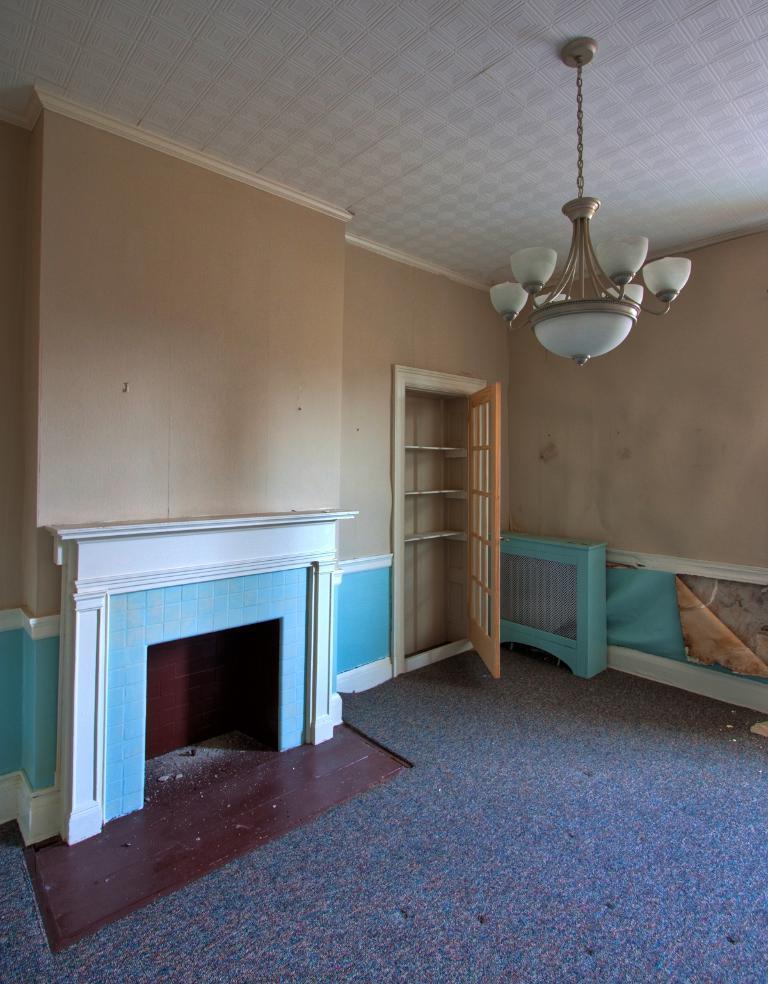How would you summarize this image in a sentence or two? In this image we can see the fire place, floor, door, some objects and the chandelier to the ceiling. 